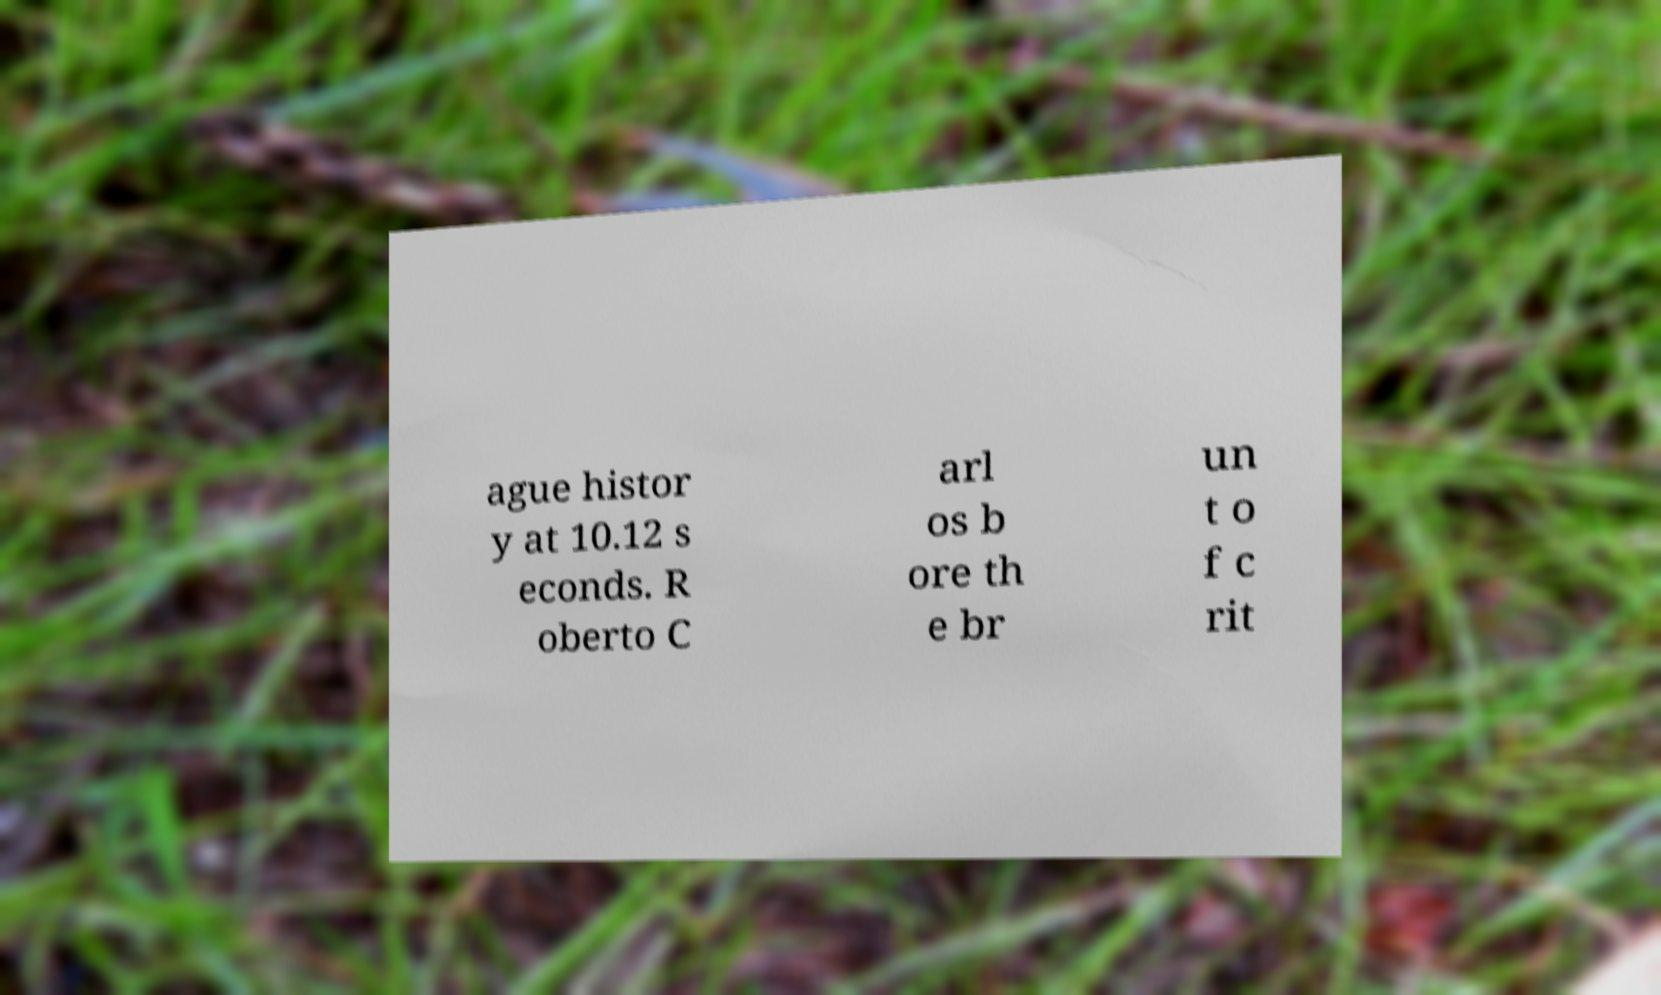Please identify and transcribe the text found in this image. ague histor y at 10.12 s econds. R oberto C arl os b ore th e br un t o f c rit 